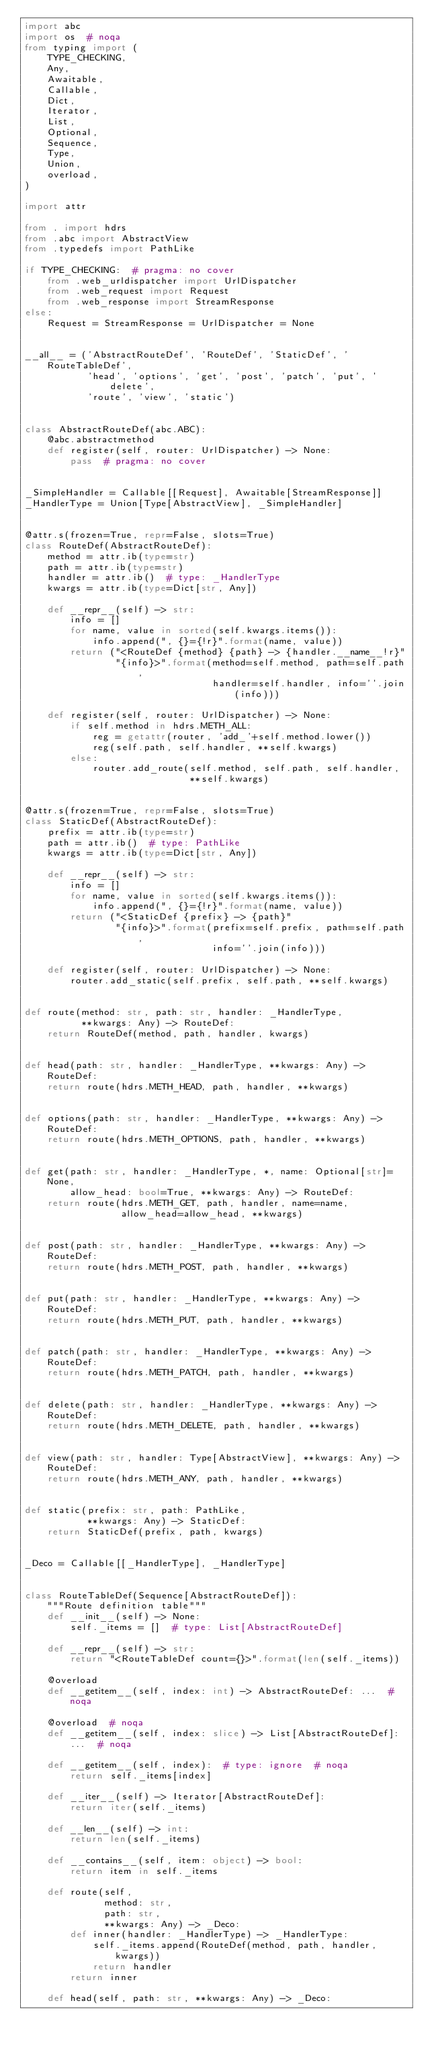<code> <loc_0><loc_0><loc_500><loc_500><_Python_>import abc
import os  # noqa
from typing import (
    TYPE_CHECKING,
    Any,
    Awaitable,
    Callable,
    Dict,
    Iterator,
    List,
    Optional,
    Sequence,
    Type,
    Union,
    overload,
)

import attr

from . import hdrs
from .abc import AbstractView
from .typedefs import PathLike

if TYPE_CHECKING:  # pragma: no cover
    from .web_urldispatcher import UrlDispatcher
    from .web_request import Request
    from .web_response import StreamResponse
else:
    Request = StreamResponse = UrlDispatcher = None


__all__ = ('AbstractRouteDef', 'RouteDef', 'StaticDef', 'RouteTableDef',
           'head', 'options', 'get', 'post', 'patch', 'put', 'delete',
           'route', 'view', 'static')


class AbstractRouteDef(abc.ABC):
    @abc.abstractmethod
    def register(self, router: UrlDispatcher) -> None:
        pass  # pragma: no cover


_SimpleHandler = Callable[[Request], Awaitable[StreamResponse]]
_HandlerType = Union[Type[AbstractView], _SimpleHandler]


@attr.s(frozen=True, repr=False, slots=True)
class RouteDef(AbstractRouteDef):
    method = attr.ib(type=str)
    path = attr.ib(type=str)
    handler = attr.ib()  # type: _HandlerType
    kwargs = attr.ib(type=Dict[str, Any])

    def __repr__(self) -> str:
        info = []
        for name, value in sorted(self.kwargs.items()):
            info.append(", {}={!r}".format(name, value))
        return ("<RouteDef {method} {path} -> {handler.__name__!r}"
                "{info}>".format(method=self.method, path=self.path,
                                 handler=self.handler, info=''.join(info)))

    def register(self, router: UrlDispatcher) -> None:
        if self.method in hdrs.METH_ALL:
            reg = getattr(router, 'add_'+self.method.lower())
            reg(self.path, self.handler, **self.kwargs)
        else:
            router.add_route(self.method, self.path, self.handler,
                             **self.kwargs)


@attr.s(frozen=True, repr=False, slots=True)
class StaticDef(AbstractRouteDef):
    prefix = attr.ib(type=str)
    path = attr.ib()  # type: PathLike
    kwargs = attr.ib(type=Dict[str, Any])

    def __repr__(self) -> str:
        info = []
        for name, value in sorted(self.kwargs.items()):
            info.append(", {}={!r}".format(name, value))
        return ("<StaticDef {prefix} -> {path}"
                "{info}>".format(prefix=self.prefix, path=self.path,
                                 info=''.join(info)))

    def register(self, router: UrlDispatcher) -> None:
        router.add_static(self.prefix, self.path, **self.kwargs)


def route(method: str, path: str, handler: _HandlerType,
          **kwargs: Any) -> RouteDef:
    return RouteDef(method, path, handler, kwargs)


def head(path: str, handler: _HandlerType, **kwargs: Any) -> RouteDef:
    return route(hdrs.METH_HEAD, path, handler, **kwargs)


def options(path: str, handler: _HandlerType, **kwargs: Any) -> RouteDef:
    return route(hdrs.METH_OPTIONS, path, handler, **kwargs)


def get(path: str, handler: _HandlerType, *, name: Optional[str]=None,
        allow_head: bool=True, **kwargs: Any) -> RouteDef:
    return route(hdrs.METH_GET, path, handler, name=name,
                 allow_head=allow_head, **kwargs)


def post(path: str, handler: _HandlerType, **kwargs: Any) -> RouteDef:
    return route(hdrs.METH_POST, path, handler, **kwargs)


def put(path: str, handler: _HandlerType, **kwargs: Any) -> RouteDef:
    return route(hdrs.METH_PUT, path, handler, **kwargs)


def patch(path: str, handler: _HandlerType, **kwargs: Any) -> RouteDef:
    return route(hdrs.METH_PATCH, path, handler, **kwargs)


def delete(path: str, handler: _HandlerType, **kwargs: Any) -> RouteDef:
    return route(hdrs.METH_DELETE, path, handler, **kwargs)


def view(path: str, handler: Type[AbstractView], **kwargs: Any) -> RouteDef:
    return route(hdrs.METH_ANY, path, handler, **kwargs)


def static(prefix: str, path: PathLike,
           **kwargs: Any) -> StaticDef:
    return StaticDef(prefix, path, kwargs)


_Deco = Callable[[_HandlerType], _HandlerType]


class RouteTableDef(Sequence[AbstractRouteDef]):
    """Route definition table"""
    def __init__(self) -> None:
        self._items = []  # type: List[AbstractRouteDef]

    def __repr__(self) -> str:
        return "<RouteTableDef count={}>".format(len(self._items))

    @overload
    def __getitem__(self, index: int) -> AbstractRouteDef: ...  # noqa

    @overload  # noqa
    def __getitem__(self, index: slice) -> List[AbstractRouteDef]: ...  # noqa

    def __getitem__(self, index):  # type: ignore  # noqa
        return self._items[index]

    def __iter__(self) -> Iterator[AbstractRouteDef]:
        return iter(self._items)

    def __len__(self) -> int:
        return len(self._items)

    def __contains__(self, item: object) -> bool:
        return item in self._items

    def route(self,
              method: str,
              path: str,
              **kwargs: Any) -> _Deco:
        def inner(handler: _HandlerType) -> _HandlerType:
            self._items.append(RouteDef(method, path, handler, kwargs))
            return handler
        return inner

    def head(self, path: str, **kwargs: Any) -> _Deco:</code> 